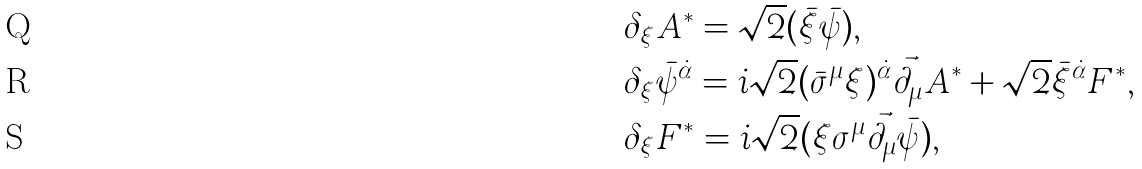<formula> <loc_0><loc_0><loc_500><loc_500>& \delta _ { \xi } A ^ { \ast } = \sqrt { 2 } ( \bar { \xi } \bar { \psi } ) , \\ & \delta _ { \xi } \bar { \psi } ^ { \dot { \alpha } } = i \sqrt { 2 } ( \bar { \sigma } ^ { \mu } \xi ) ^ { \dot { \alpha } } \vec { \partial } _ { \mu } A ^ { \ast } + \sqrt { 2 } \bar { \xi } ^ { \dot { \alpha } } F ^ { \ast } , \\ & \delta _ { \xi } F ^ { \ast } = i \sqrt { 2 } ( \xi \sigma ^ { \mu } \vec { \partial } _ { \mu } \bar { \psi } ) ,</formula> 